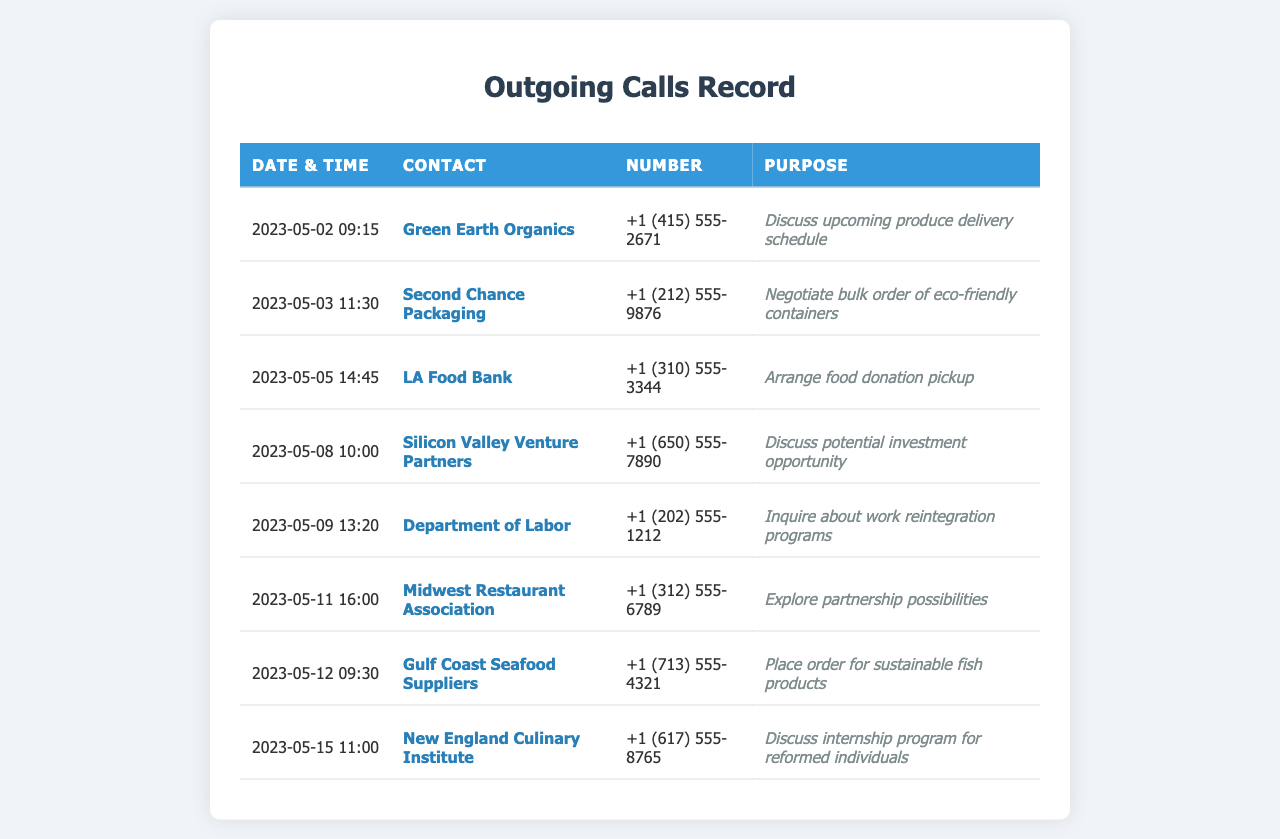What is the date of the earliest call listed? The earliest call in the list is on May 2, 2023.
Answer: 2023-05-02 Who was called on May 5, 2023? The contact called on May 5, 2023, was LA Food Bank.
Answer: LA Food Bank What was the purpose of the call to Gulf Coast Seafood Suppliers? The purpose of the call to Gulf Coast Seafood Suppliers was to place an order for sustainable fish products.
Answer: Place order for sustainable fish products How many suppliers or partners were contacted during the week of May 8 to May 15, 2023? Two calls were made during the week of May 8 to May 15, 2023: one to New England Culinary Institute and another to Gulf Coast Seafood Suppliers.
Answer: 2 What was discussed in the call with Silicon Valley Venture Partners? The call with Silicon Valley Venture Partners was to discuss a potential investment opportunity.
Answer: Discuss potential investment opportunity Which organization was contacted to discuss internship programs? The organization contacted to discuss internship programs was New England Culinary Institute.
Answer: New England Culinary Institute How many calls were made in total? There were a total of eight calls made according to the document.
Answer: 8 What type of products were negotiated with Second Chance Packaging? The type of products negotiated with Second Chance Packaging were eco-friendly containers.
Answer: Eco-friendly containers What time was the call to the Department of Labor? The call to the Department of Labor was made at 13:20.
Answer: 13:20 